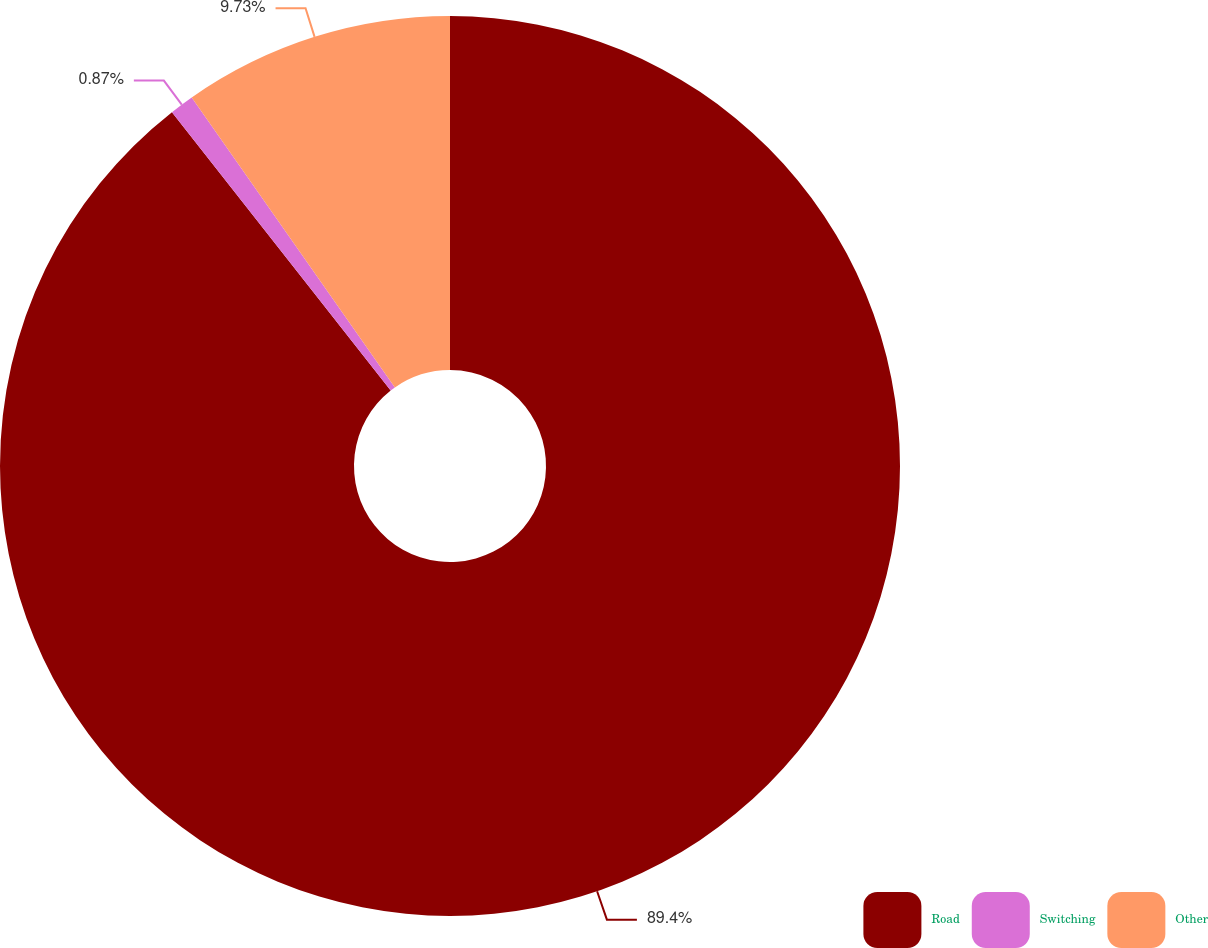Convert chart to OTSL. <chart><loc_0><loc_0><loc_500><loc_500><pie_chart><fcel>Road<fcel>Switching<fcel>Other<nl><fcel>89.4%<fcel>0.87%<fcel>9.73%<nl></chart> 